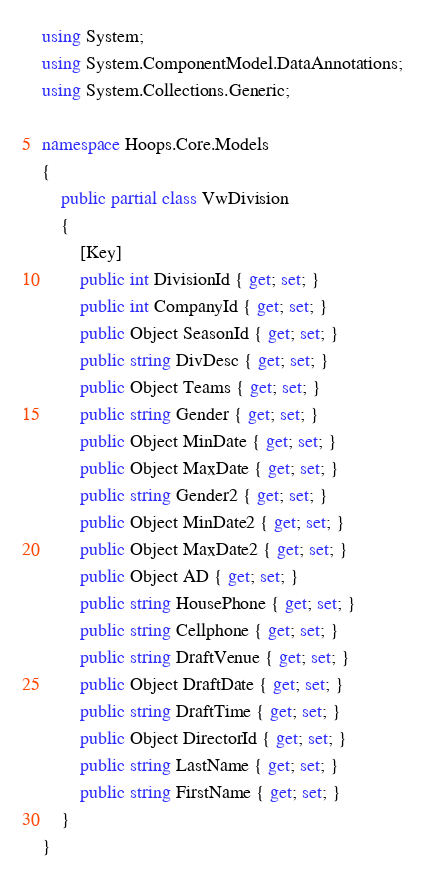<code> <loc_0><loc_0><loc_500><loc_500><_C#_>using System;
using System.ComponentModel.DataAnnotations;
using System.Collections.Generic;

namespace Hoops.Core.Models
{
    public partial class VwDivision
    {
        [Key]
        public int DivisionId { get; set; }
        public int CompanyId { get; set; }
        public Object SeasonId { get; set; }
        public string DivDesc { get; set; }
        public Object Teams { get; set; }
        public string Gender { get; set; }
        public Object MinDate { get; set; }
        public Object MaxDate { get; set; }
        public string Gender2 { get; set; }
        public Object MinDate2 { get; set; }
        public Object MaxDate2 { get; set; }
        public Object AD { get; set; }
        public string HousePhone { get; set; }
        public string Cellphone { get; set; }
        public string DraftVenue { get; set; }
        public Object DraftDate { get; set; }
        public string DraftTime { get; set; }
        public Object DirectorId { get; set; }
        public string LastName { get; set; }
        public string FirstName { get; set; }
    }
}
</code> 